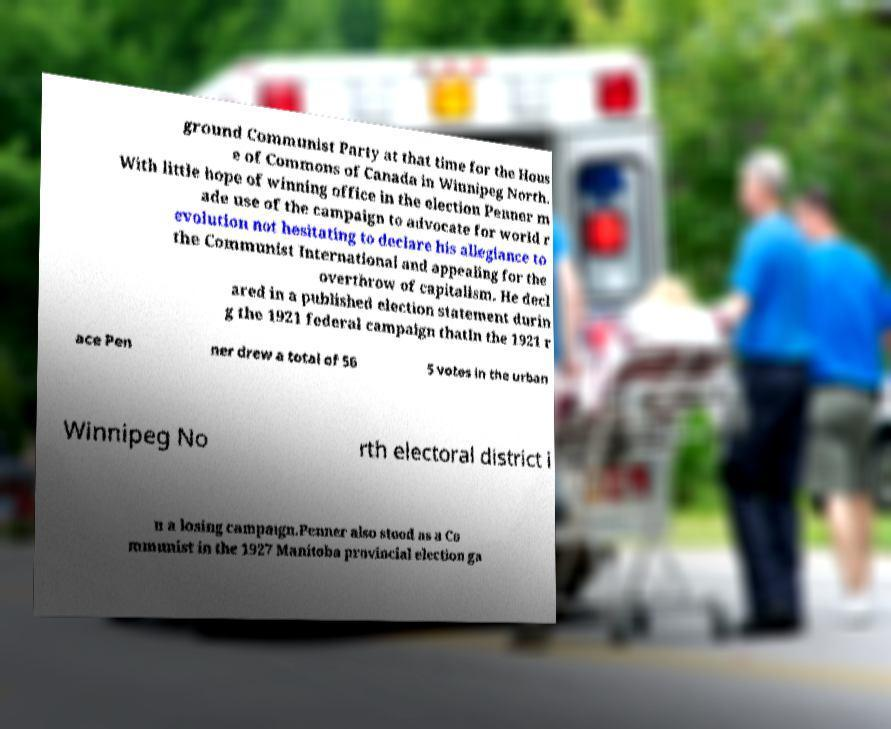Can you read and provide the text displayed in the image?This photo seems to have some interesting text. Can you extract and type it out for me? ground Communist Party at that time for the Hous e of Commons of Canada in Winnipeg North. With little hope of winning office in the election Penner m ade use of the campaign to advocate for world r evolution not hesitating to declare his allegiance to the Communist International and appealing for the overthrow of capitalism. He decl ared in a published election statement durin g the 1921 federal campaign thatIn the 1921 r ace Pen ner drew a total of 56 5 votes in the urban Winnipeg No rth electoral district i n a losing campaign.Penner also stood as a Co mmunist in the 1927 Manitoba provincial election ga 